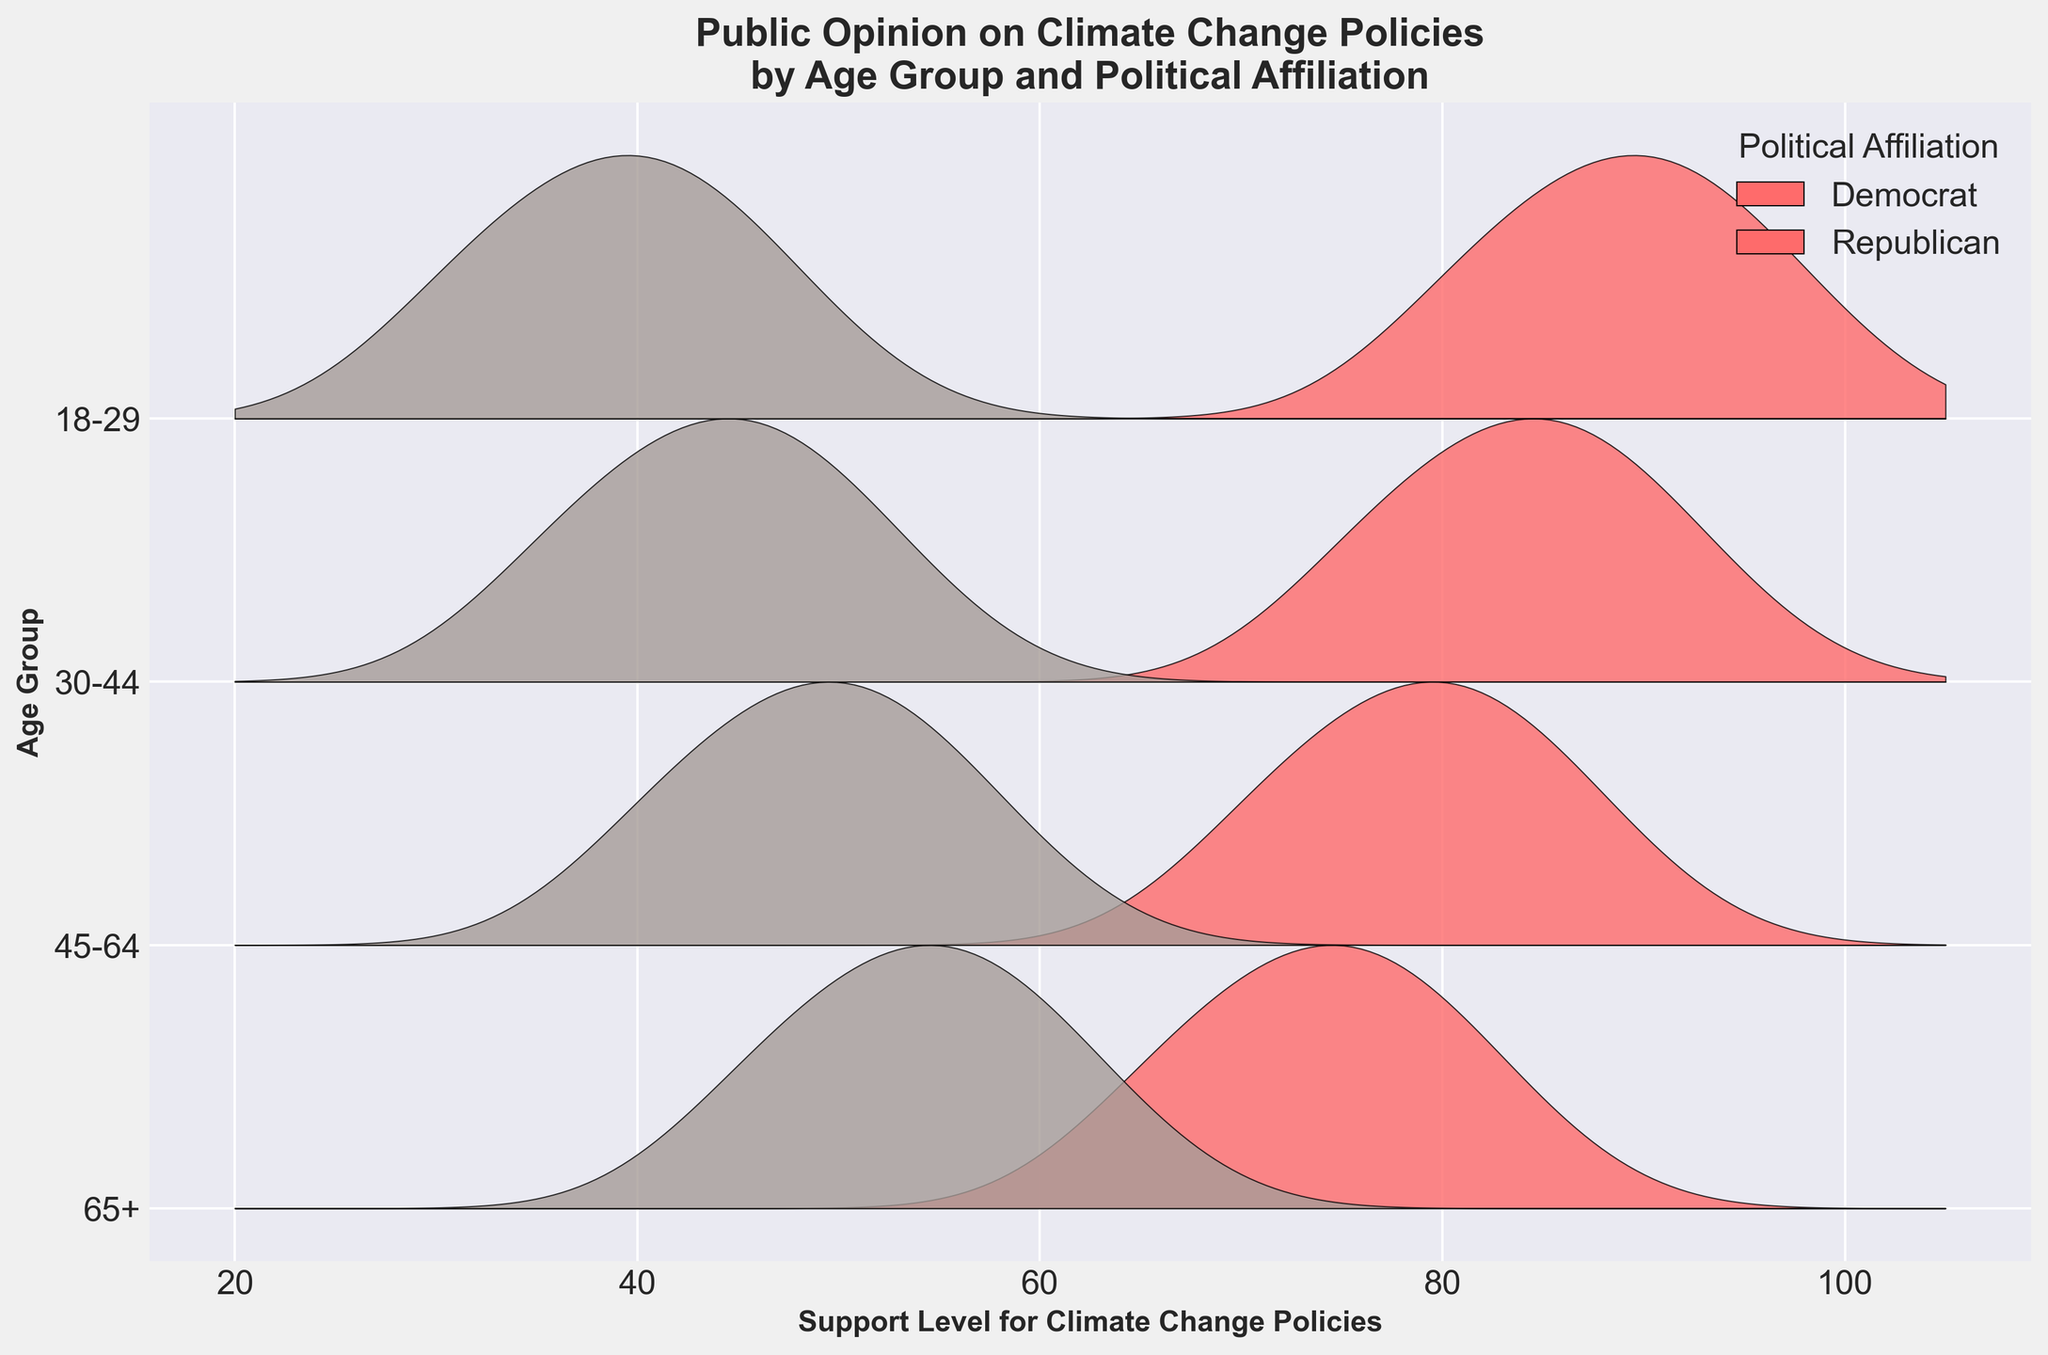What is the title of the Ridgeline plot? The title of the Ridgeline plot is usually found at the top of the figure.
Answer: Public Opinion on Climate Change Policies by Age Group and Political Affiliation What are the age groups represented in the plot? The age groups are listed along the Y-axis, with labels for each group in reverse order.
Answer: 18-29, 30-44, 45-64, 65+ Which political affiliation shows higher support for climate change policies in the 18-29 age group? Compare the support levels of Democrats and Republicans for the 18-29 age group; Democrats have higher support levels.
Answer: Democrats What is the highest density of support for climate change policies among Republicans in the 45-64 age group? Identify the peak of the density curve for Republicans in the 45-64 age group; the highest density corresponds to the support level of 50.
Answer: 0.04 Which age group shows the greatest variation in support levels among Democrats? Look for the range of support levels and their densities for each age group among Democrats; the widest spread indicates the greatest variation.
Answer: 18-29 Compare the peak support levels for 30-44 age group Democrats and Republicans. Which is higher? Identify the highest density peak for both Democrats and Republicans in the 30-44 age group; compare their peaks.
Answer: Democrats What is the general trend of support for climate change policies among Republicans as age increases? Examine the shapes and peaks of the density curves for Republicans across different age groups; as age increases, the support levels slightly shift towards higher levels.
Answer: Support slightly increases How does the density of support for climate change policies in the 65+ age group differ between Democrats and Republicans? Compare the density curves for the 65+ age group between Democrats and Republicans; Democrats have higher support levels and densities.
Answer: Democrats have higher densities What is a notable trend in the support for climate change policies among all age groups for Democrats? Examine the peak support levels and densities for Democrats in each age group; the general trend shows high support levels consistently from 65 down to 18-29.
Answer: High support levels across all ages Which political affiliation shows a more significant shift in support for climate change policies as age increases? Compare the changes in support levels for both political affiliations across age groups; Republicans show a more noticeable shift towards higher support levels with age.
Answer: Republicans 